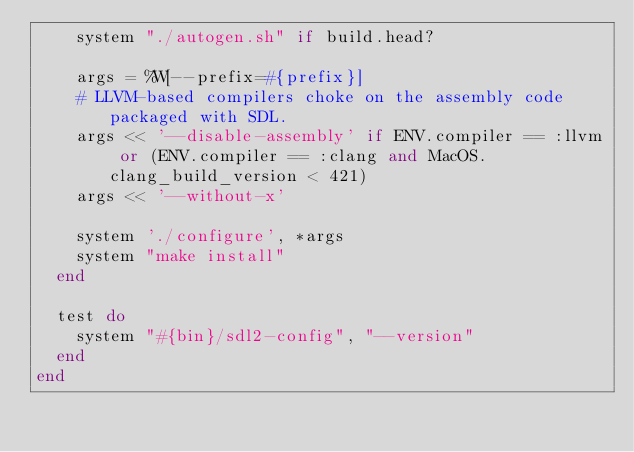<code> <loc_0><loc_0><loc_500><loc_500><_Ruby_>    system "./autogen.sh" if build.head?

    args = %W[--prefix=#{prefix}]
    # LLVM-based compilers choke on the assembly code packaged with SDL.
    args << '--disable-assembly' if ENV.compiler == :llvm or (ENV.compiler == :clang and MacOS.clang_build_version < 421)
    args << '--without-x'

    system './configure', *args
    system "make install"
  end

  test do
    system "#{bin}/sdl2-config", "--version"
  end
end
</code> 